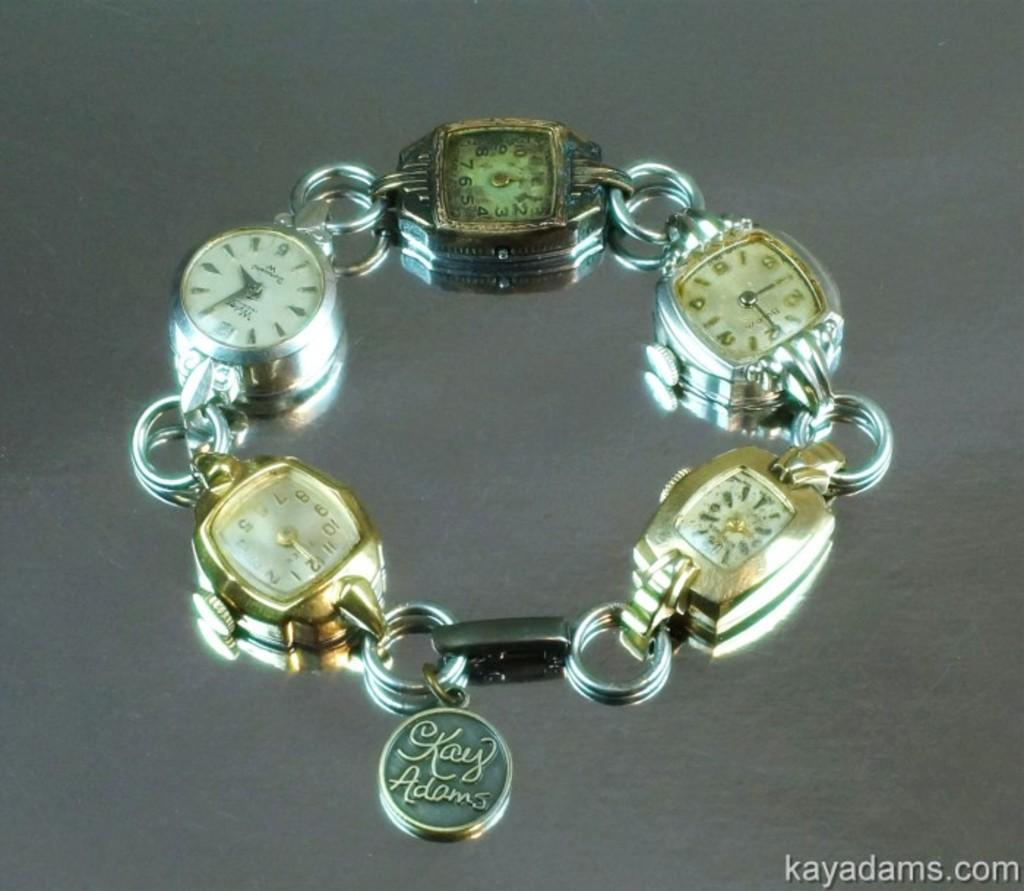<image>
Describe the image concisely. A bracelet made of watches with a Kay Adams pendant. 